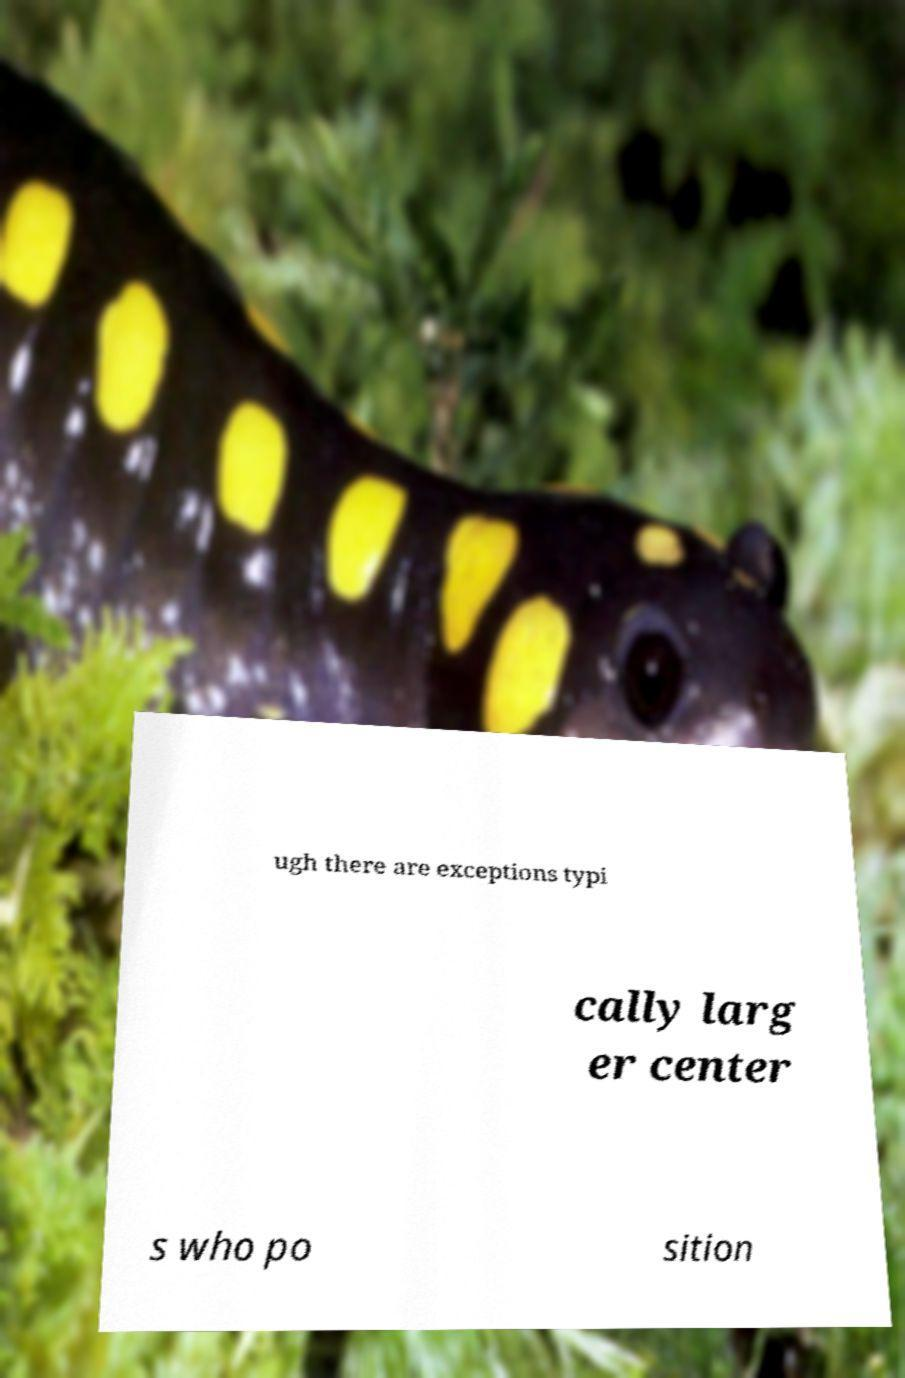Please identify and transcribe the text found in this image. ugh there are exceptions typi cally larg er center s who po sition 